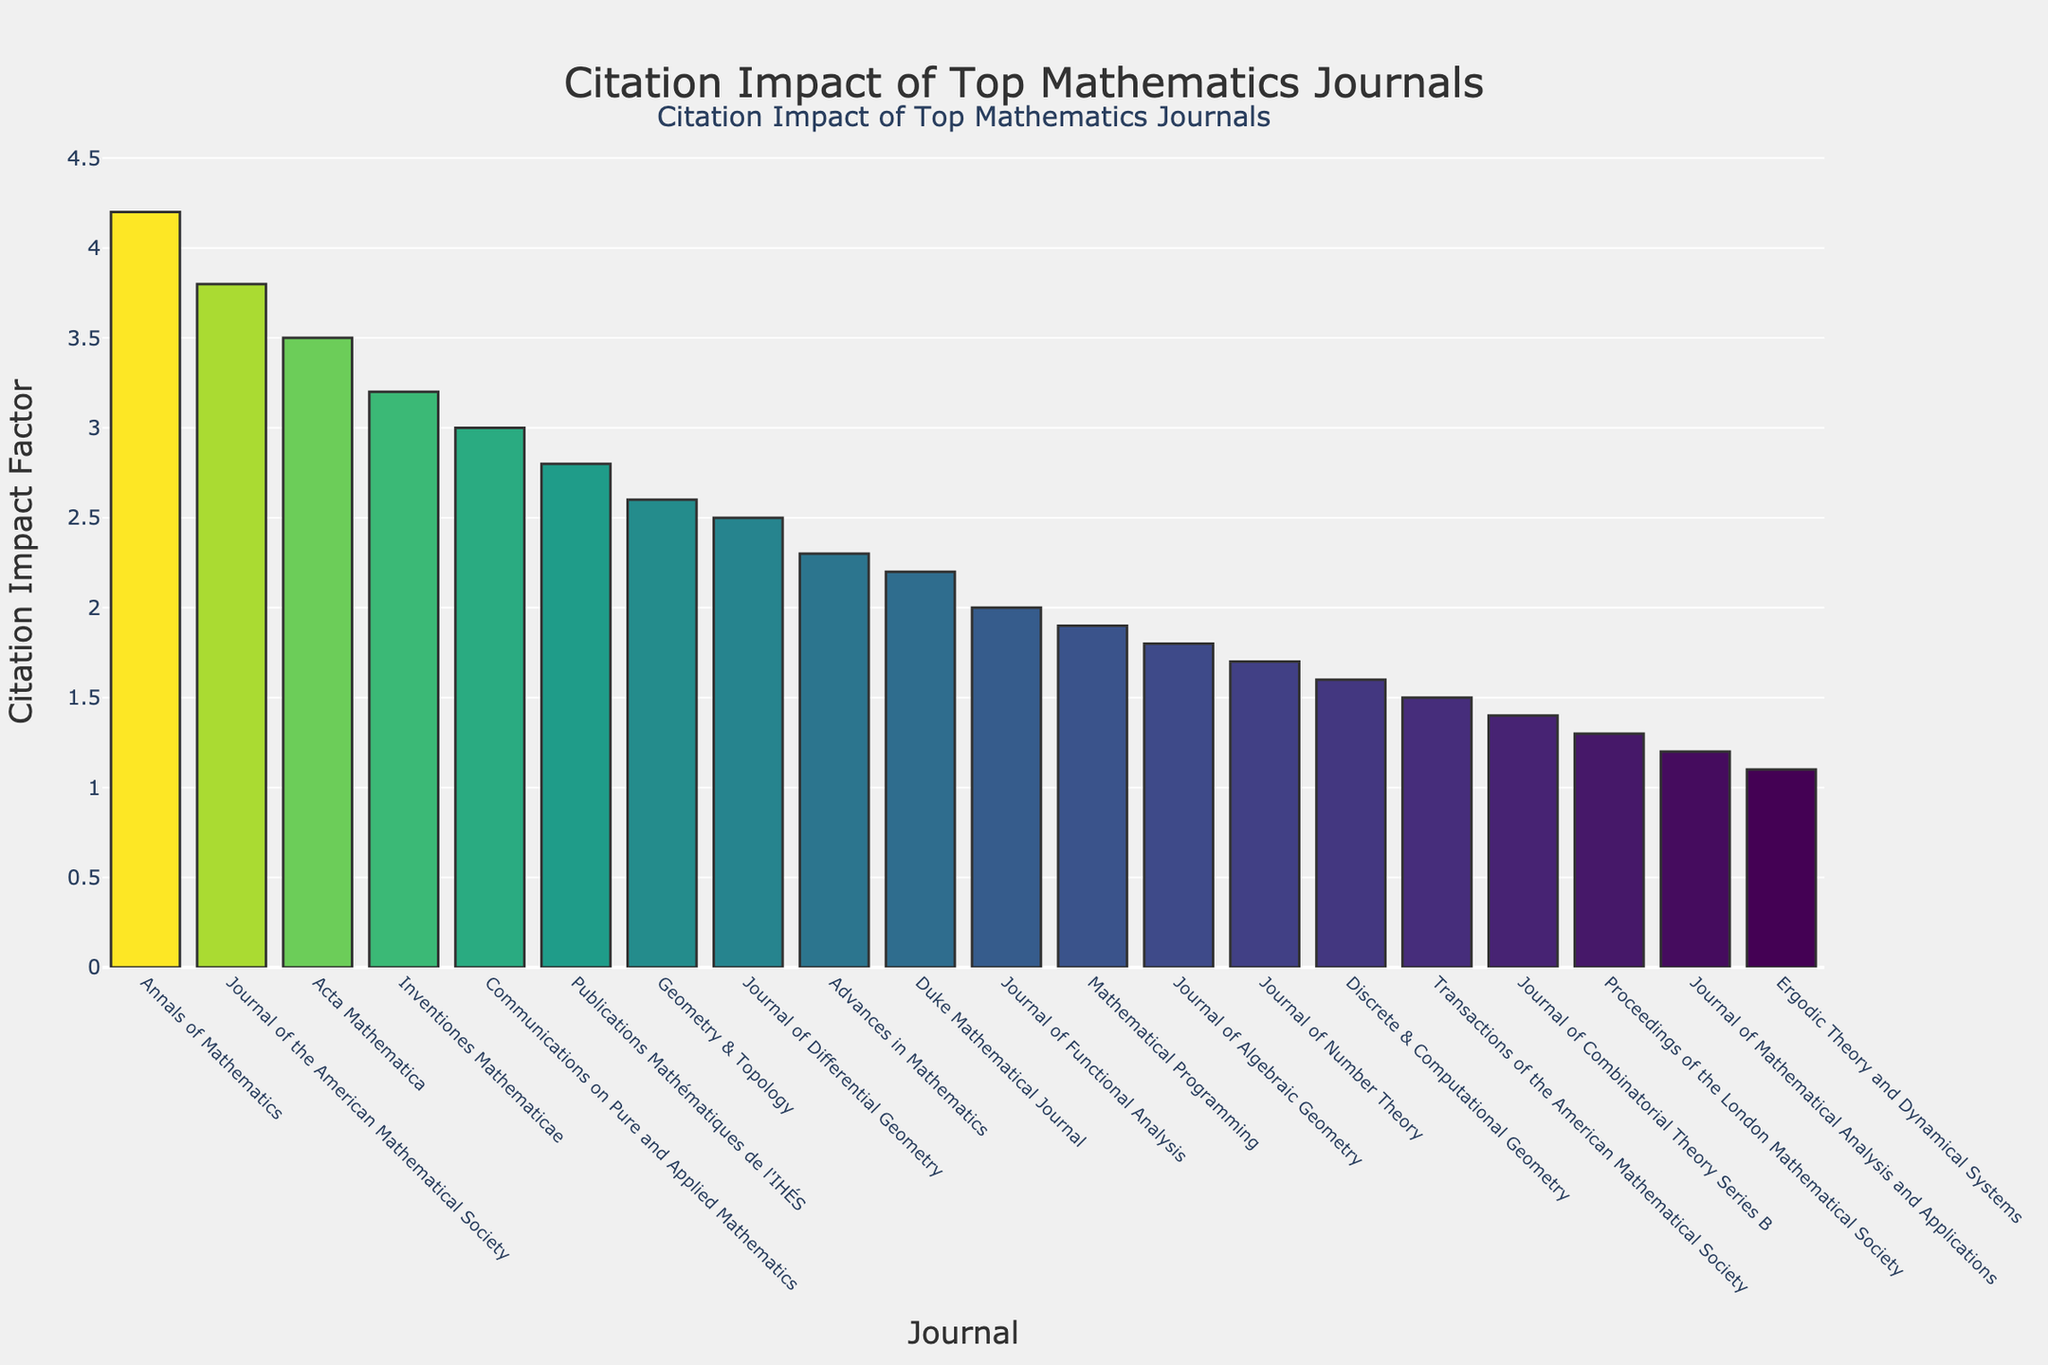Which journal has the highest citation impact factor? From the bar chart, the highest bar corresponds to the "Annals of Mathematics". This journal is positioned at the top in the ordered list by citation impact factor.
Answer: Annals of Mathematics What is the difference in citation impact factor between the "Annals of Mathematics" and "Journal of the American Mathematical Society"? From the chart, the impact factor for "Annals of Mathematics" is 4.2 and for "Journal of the American Mathematical Society" it is 3.8. The difference is 4.2 - 3.8 = 0.4.
Answer: 0.4 Which journals have a citation impact factor greater than 3.0? Journals with bars extending above the 3.0 mark are "Annals of Mathematics" (4.2), "Journal of the American Mathematical Society" (3.8), "Acta Mathematica" (3.5), and "Inventiones Mathematicae" (3.2).
Answer: Annals of Mathematics, Journal of the American Mathematical Society, Acta Mathematica, Inventiones Mathematicae How many journals have a citation impact factor lower than 1.5? Bars that do not reach the 1.5 mark are counted. These are "Journal of Combinatorial Theory Series B" (1.4), "Proceedings of the London Mathematical Society" (1.3), "Journal of Mathematical Analysis and Applications" (1.2), and "Ergodic Theory and Dynamical Systems" (1.1). So, there are 4 journals.
Answer: 4 What is the average citation impact factor of the journals listed? Add all the citation impact factors and divide by the number of journals. (4.2 + 3.8 + 3.5 + 3.2 + 3.0 + 2.8 + 2.6 + 2.5 + 2.3 + 2.2 + 2.0 + 1.9 + 1.8 + 1.7 + 1.6 + 1.5 + 1.4 + 1.3 + 1.2 + 1.1) / 20 = 2.375.
Answer: 2.375 What is the median citation impact factor of the journals? Sort the citation impact factors and find the middle value. The sorted values are: 1.1, 1.2, 1.3, 1.4, 1.5, 1.6, 1.7, 1.8, 1.9, 2.0, 2.2, 2.3, 2.5, 2.6, 2.8, 3.0, 3.2, 3.5, 3.8, 4.2. There are 20 journals, so the median is the average of the 10th and 11th values: (2.0 + 2.2) / 2 = 2.1.
Answer: 2.1 By how much does the citation impact factor of the "Duke Mathematical Journal" exceed that of the "Journal of Combinatorial Theory Series B"? The "Duke Mathematical Journal" has a citation impact factor of 2.2 and the "Journal of Combinatorial Theory Series B" has 1.4. The difference is 2.2 - 1.4 = 0.8.
Answer: 0.8 Which specialization has the least influence based on the citation impact factors? The lowest bar in the chart is for "Ergodic Theory and Dynamical Systems" with a citation impact factor of 1.1, indicating it has the least influence.
Answer: Ergodic Theory and Dynamical Systems What range of citation impact factors is covered by the top 5 journals? The citation impact factors for the top 5 journals are 4.2, 3.8, 3.5, 3.2, and 3.0. The range is the difference between the highest and lowest values: 4.2 - 3.0 = 1.2.
Answer: 1.2 